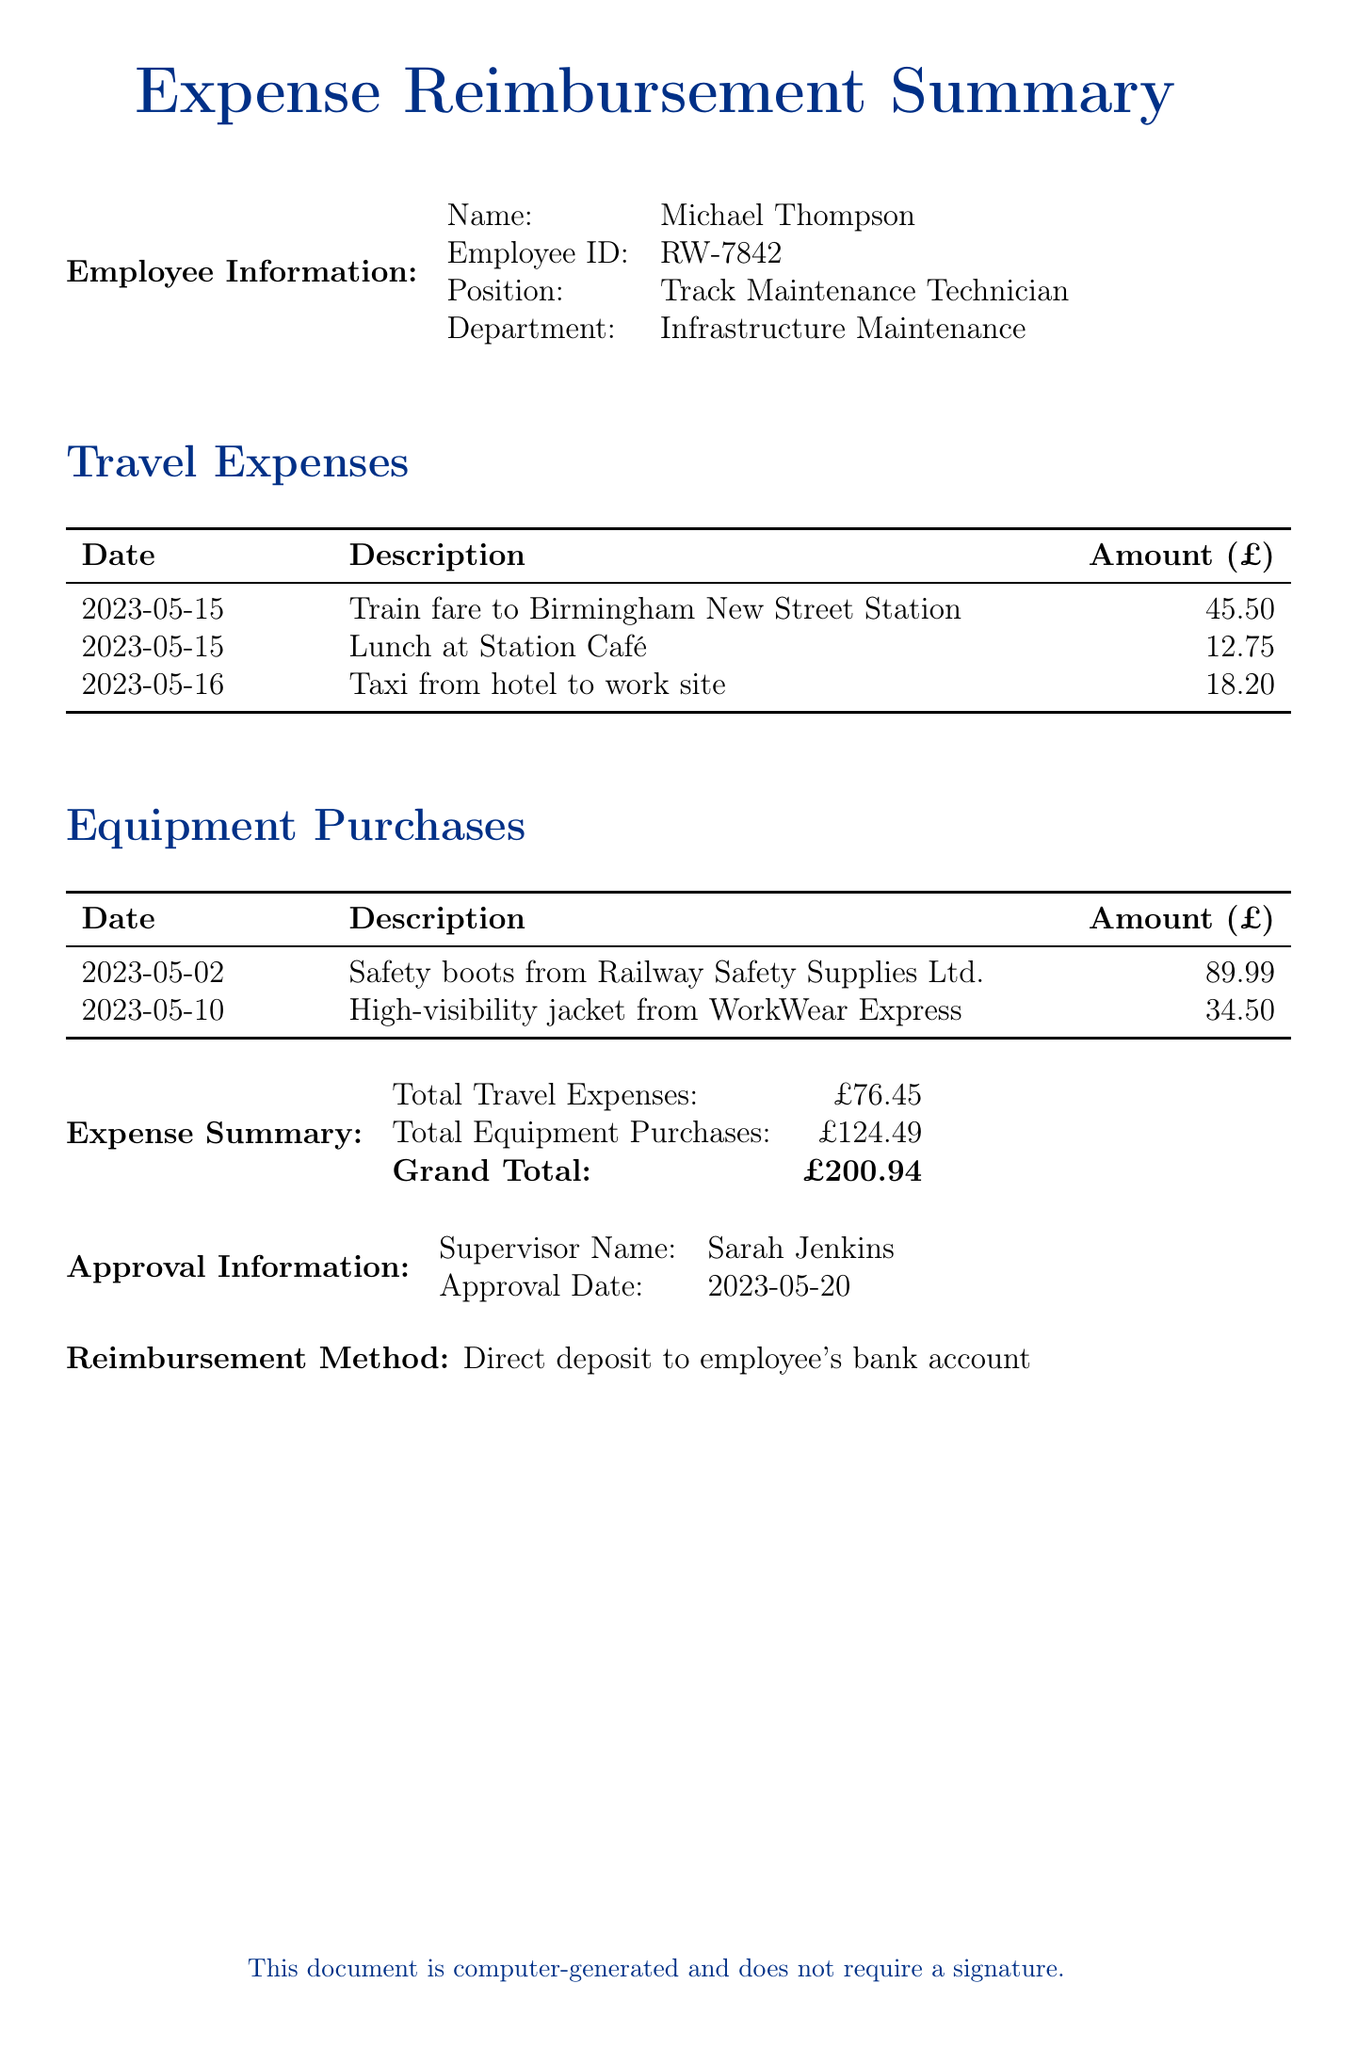What is the employee's name? The document provides the name of the employee at the beginning under Employee Information.
Answer: Michael Thompson What is the total amount for travel expenses? The total travel expenses are summarized in the Expense Summary section, listing the amount clearly.
Answer: £76.45 What safety equipment is purchased? The document lists the equipment purchases that include specific items under Equipment Purchases.
Answer: Safety boots Who is the supervisor for approval? The supervisor's name is specified in the Approval Information section.
Answer: Sarah Jenkins What is the reimbursement method? The method of reimbursement is mentioned at the end of the document.
Answer: Direct deposit to employee's bank account What date was the approval granted? The approval date is listed in the Approval Information section.
Answer: 2023-05-20 What is the grand total of all expenses? The grand total of all expenses is detailed in the Expense Summary section at the bottom of the document.
Answer: £200.94 On what date did Michael spend on lunch? The date of the lunch expense is provided under Travel Expenses.
Answer: 2023-05-15 